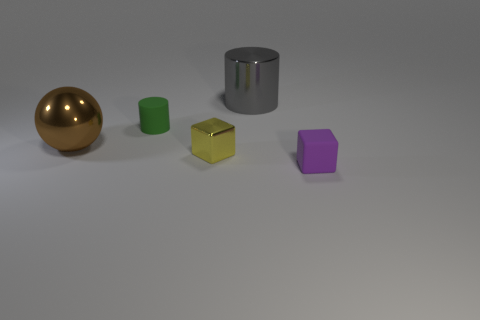There is another rubber thing that is the same shape as the large gray thing; what is its size?
Keep it short and to the point. Small. Are there fewer tiny matte cubes on the left side of the brown thing than tiny purple cubes?
Give a very brief answer. Yes. Is there a purple matte object of the same size as the green cylinder?
Keep it short and to the point. Yes. The big cylinder has what color?
Keep it short and to the point. Gray. Do the purple object and the shiny cube have the same size?
Your answer should be very brief. Yes. How many objects are red shiny things or small shiny cubes?
Provide a succinct answer. 1. Are there the same number of large gray metal things on the right side of the gray thing and purple matte blocks?
Provide a short and direct response. No. There is a cylinder on the right side of the cube on the left side of the purple cube; are there any small yellow metallic cubes that are behind it?
Make the answer very short. No. What color is the cylinder that is made of the same material as the tiny yellow thing?
Provide a succinct answer. Gray. Do the rubber object behind the brown metal thing and the tiny matte block have the same color?
Offer a very short reply. No. 